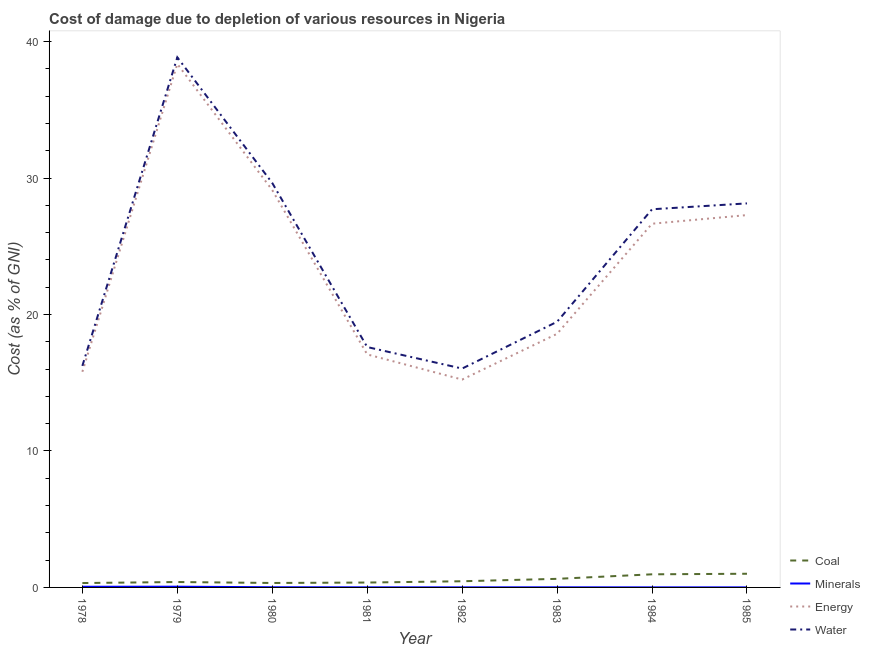Is the number of lines equal to the number of legend labels?
Provide a succinct answer. Yes. What is the cost of damage due to depletion of minerals in 1984?
Your answer should be very brief. 0.01. Across all years, what is the maximum cost of damage due to depletion of water?
Offer a terse response. 38.85. Across all years, what is the minimum cost of damage due to depletion of energy?
Keep it short and to the point. 15.24. In which year was the cost of damage due to depletion of minerals maximum?
Keep it short and to the point. 1979. In which year was the cost of damage due to depletion of energy minimum?
Make the answer very short. 1982. What is the total cost of damage due to depletion of coal in the graph?
Your response must be concise. 4.45. What is the difference between the cost of damage due to depletion of water in 1981 and that in 1982?
Ensure brevity in your answer.  1.58. What is the difference between the cost of damage due to depletion of water in 1984 and the cost of damage due to depletion of energy in 1980?
Ensure brevity in your answer.  -1.41. What is the average cost of damage due to depletion of energy per year?
Provide a succinct answer. 23.52. In the year 1979, what is the difference between the cost of damage due to depletion of energy and cost of damage due to depletion of coal?
Provide a succinct answer. 37.97. In how many years, is the cost of damage due to depletion of water greater than 32 %?
Give a very brief answer. 1. What is the ratio of the cost of damage due to depletion of energy in 1978 to that in 1979?
Provide a short and direct response. 0.41. Is the cost of damage due to depletion of energy in 1978 less than that in 1980?
Offer a very short reply. Yes. What is the difference between the highest and the second highest cost of damage due to depletion of coal?
Provide a short and direct response. 0.04. What is the difference between the highest and the lowest cost of damage due to depletion of coal?
Your response must be concise. 0.68. Is it the case that in every year, the sum of the cost of damage due to depletion of energy and cost of damage due to depletion of minerals is greater than the sum of cost of damage due to depletion of coal and cost of damage due to depletion of water?
Offer a terse response. Yes. Is it the case that in every year, the sum of the cost of damage due to depletion of coal and cost of damage due to depletion of minerals is greater than the cost of damage due to depletion of energy?
Your answer should be compact. No. Does the cost of damage due to depletion of minerals monotonically increase over the years?
Provide a succinct answer. No. Is the cost of damage due to depletion of energy strictly less than the cost of damage due to depletion of coal over the years?
Offer a very short reply. No. How many years are there in the graph?
Keep it short and to the point. 8. What is the difference between two consecutive major ticks on the Y-axis?
Your answer should be compact. 10. Are the values on the major ticks of Y-axis written in scientific E-notation?
Give a very brief answer. No. How many legend labels are there?
Your response must be concise. 4. How are the legend labels stacked?
Make the answer very short. Vertical. What is the title of the graph?
Ensure brevity in your answer.  Cost of damage due to depletion of various resources in Nigeria . Does "Offering training" appear as one of the legend labels in the graph?
Provide a succinct answer. No. What is the label or title of the Y-axis?
Make the answer very short. Cost (as % of GNI). What is the Cost (as % of GNI) of Coal in 1978?
Offer a very short reply. 0.32. What is the Cost (as % of GNI) of Minerals in 1978?
Provide a short and direct response. 0.05. What is the Cost (as % of GNI) of Energy in 1978?
Provide a succinct answer. 15.81. What is the Cost (as % of GNI) in Water in 1978?
Make the answer very short. 16.24. What is the Cost (as % of GNI) of Coal in 1979?
Provide a succinct answer. 0.4. What is the Cost (as % of GNI) of Minerals in 1979?
Offer a very short reply. 0.05. What is the Cost (as % of GNI) in Energy in 1979?
Keep it short and to the point. 38.37. What is the Cost (as % of GNI) in Water in 1979?
Provide a succinct answer. 38.85. What is the Cost (as % of GNI) in Coal in 1980?
Give a very brief answer. 0.33. What is the Cost (as % of GNI) of Minerals in 1980?
Keep it short and to the point. 0.01. What is the Cost (as % of GNI) of Energy in 1980?
Give a very brief answer. 29.12. What is the Cost (as % of GNI) of Water in 1980?
Keep it short and to the point. 29.64. What is the Cost (as % of GNI) of Coal in 1981?
Provide a short and direct response. 0.36. What is the Cost (as % of GNI) of Minerals in 1981?
Offer a very short reply. 0.01. What is the Cost (as % of GNI) in Energy in 1981?
Your answer should be very brief. 17.08. What is the Cost (as % of GNI) in Water in 1981?
Make the answer very short. 17.62. What is the Cost (as % of GNI) in Coal in 1982?
Give a very brief answer. 0.45. What is the Cost (as % of GNI) in Minerals in 1982?
Make the answer very short. 0.01. What is the Cost (as % of GNI) in Energy in 1982?
Offer a very short reply. 15.24. What is the Cost (as % of GNI) of Water in 1982?
Your answer should be very brief. 16.04. What is the Cost (as % of GNI) of Coal in 1983?
Your response must be concise. 0.63. What is the Cost (as % of GNI) in Minerals in 1983?
Offer a terse response. 0.01. What is the Cost (as % of GNI) in Energy in 1983?
Ensure brevity in your answer.  18.59. What is the Cost (as % of GNI) of Water in 1983?
Provide a short and direct response. 19.47. What is the Cost (as % of GNI) of Coal in 1984?
Provide a succinct answer. 0.96. What is the Cost (as % of GNI) of Minerals in 1984?
Offer a terse response. 0.01. What is the Cost (as % of GNI) of Energy in 1984?
Offer a terse response. 26.66. What is the Cost (as % of GNI) in Water in 1984?
Make the answer very short. 27.72. What is the Cost (as % of GNI) of Coal in 1985?
Ensure brevity in your answer.  1. What is the Cost (as % of GNI) in Minerals in 1985?
Offer a very short reply. 0. What is the Cost (as % of GNI) in Energy in 1985?
Ensure brevity in your answer.  27.29. What is the Cost (as % of GNI) in Water in 1985?
Your response must be concise. 28.15. Across all years, what is the maximum Cost (as % of GNI) in Coal?
Provide a short and direct response. 1. Across all years, what is the maximum Cost (as % of GNI) of Minerals?
Make the answer very short. 0.05. Across all years, what is the maximum Cost (as % of GNI) of Energy?
Offer a terse response. 38.37. Across all years, what is the maximum Cost (as % of GNI) of Water?
Provide a succinct answer. 38.85. Across all years, what is the minimum Cost (as % of GNI) in Coal?
Offer a very short reply. 0.32. Across all years, what is the minimum Cost (as % of GNI) in Minerals?
Your answer should be very brief. 0. Across all years, what is the minimum Cost (as % of GNI) in Energy?
Make the answer very short. 15.24. Across all years, what is the minimum Cost (as % of GNI) in Water?
Offer a very short reply. 16.04. What is the total Cost (as % of GNI) of Coal in the graph?
Provide a succinct answer. 4.45. What is the total Cost (as % of GNI) of Minerals in the graph?
Your answer should be very brief. 0.15. What is the total Cost (as % of GNI) in Energy in the graph?
Your response must be concise. 188.15. What is the total Cost (as % of GNI) in Water in the graph?
Your answer should be very brief. 193.73. What is the difference between the Cost (as % of GNI) of Coal in 1978 and that in 1979?
Provide a succinct answer. -0.08. What is the difference between the Cost (as % of GNI) of Minerals in 1978 and that in 1979?
Make the answer very short. -0. What is the difference between the Cost (as % of GNI) in Energy in 1978 and that in 1979?
Provide a succinct answer. -22.56. What is the difference between the Cost (as % of GNI) of Water in 1978 and that in 1979?
Give a very brief answer. -22.62. What is the difference between the Cost (as % of GNI) in Coal in 1978 and that in 1980?
Your answer should be very brief. -0.01. What is the difference between the Cost (as % of GNI) in Minerals in 1978 and that in 1980?
Ensure brevity in your answer.  0.04. What is the difference between the Cost (as % of GNI) of Energy in 1978 and that in 1980?
Your answer should be very brief. -13.32. What is the difference between the Cost (as % of GNI) of Water in 1978 and that in 1980?
Make the answer very short. -13.41. What is the difference between the Cost (as % of GNI) in Coal in 1978 and that in 1981?
Offer a terse response. -0.04. What is the difference between the Cost (as % of GNI) in Minerals in 1978 and that in 1981?
Offer a terse response. 0.04. What is the difference between the Cost (as % of GNI) in Energy in 1978 and that in 1981?
Keep it short and to the point. -1.27. What is the difference between the Cost (as % of GNI) of Water in 1978 and that in 1981?
Your answer should be very brief. -1.38. What is the difference between the Cost (as % of GNI) of Coal in 1978 and that in 1982?
Provide a succinct answer. -0.13. What is the difference between the Cost (as % of GNI) of Minerals in 1978 and that in 1982?
Offer a very short reply. 0.04. What is the difference between the Cost (as % of GNI) in Energy in 1978 and that in 1982?
Give a very brief answer. 0.57. What is the difference between the Cost (as % of GNI) of Water in 1978 and that in 1982?
Your answer should be very brief. 0.2. What is the difference between the Cost (as % of GNI) of Coal in 1978 and that in 1983?
Ensure brevity in your answer.  -0.31. What is the difference between the Cost (as % of GNI) of Minerals in 1978 and that in 1983?
Ensure brevity in your answer.  0.04. What is the difference between the Cost (as % of GNI) in Energy in 1978 and that in 1983?
Offer a terse response. -2.78. What is the difference between the Cost (as % of GNI) in Water in 1978 and that in 1983?
Ensure brevity in your answer.  -3.23. What is the difference between the Cost (as % of GNI) of Coal in 1978 and that in 1984?
Make the answer very short. -0.64. What is the difference between the Cost (as % of GNI) of Minerals in 1978 and that in 1984?
Offer a very short reply. 0.04. What is the difference between the Cost (as % of GNI) of Energy in 1978 and that in 1984?
Provide a short and direct response. -10.85. What is the difference between the Cost (as % of GNI) of Water in 1978 and that in 1984?
Your answer should be compact. -11.48. What is the difference between the Cost (as % of GNI) in Coal in 1978 and that in 1985?
Offer a very short reply. -0.68. What is the difference between the Cost (as % of GNI) in Minerals in 1978 and that in 1985?
Give a very brief answer. 0.05. What is the difference between the Cost (as % of GNI) of Energy in 1978 and that in 1985?
Give a very brief answer. -11.48. What is the difference between the Cost (as % of GNI) of Water in 1978 and that in 1985?
Your response must be concise. -11.91. What is the difference between the Cost (as % of GNI) in Coal in 1979 and that in 1980?
Your answer should be very brief. 0.07. What is the difference between the Cost (as % of GNI) of Minerals in 1979 and that in 1980?
Keep it short and to the point. 0.04. What is the difference between the Cost (as % of GNI) of Energy in 1979 and that in 1980?
Provide a succinct answer. 9.25. What is the difference between the Cost (as % of GNI) of Water in 1979 and that in 1980?
Your response must be concise. 9.21. What is the difference between the Cost (as % of GNI) of Coal in 1979 and that in 1981?
Keep it short and to the point. 0.04. What is the difference between the Cost (as % of GNI) in Minerals in 1979 and that in 1981?
Make the answer very short. 0.05. What is the difference between the Cost (as % of GNI) in Energy in 1979 and that in 1981?
Offer a terse response. 21.29. What is the difference between the Cost (as % of GNI) in Water in 1979 and that in 1981?
Offer a terse response. 21.24. What is the difference between the Cost (as % of GNI) of Coal in 1979 and that in 1982?
Offer a terse response. -0.06. What is the difference between the Cost (as % of GNI) of Minerals in 1979 and that in 1982?
Your response must be concise. 0.05. What is the difference between the Cost (as % of GNI) in Energy in 1979 and that in 1982?
Ensure brevity in your answer.  23.13. What is the difference between the Cost (as % of GNI) of Water in 1979 and that in 1982?
Your answer should be compact. 22.81. What is the difference between the Cost (as % of GNI) of Coal in 1979 and that in 1983?
Your answer should be very brief. -0.23. What is the difference between the Cost (as % of GNI) in Minerals in 1979 and that in 1983?
Offer a terse response. 0.05. What is the difference between the Cost (as % of GNI) of Energy in 1979 and that in 1983?
Your answer should be very brief. 19.78. What is the difference between the Cost (as % of GNI) in Water in 1979 and that in 1983?
Provide a short and direct response. 19.38. What is the difference between the Cost (as % of GNI) in Coal in 1979 and that in 1984?
Give a very brief answer. -0.56. What is the difference between the Cost (as % of GNI) in Minerals in 1979 and that in 1984?
Your response must be concise. 0.05. What is the difference between the Cost (as % of GNI) in Energy in 1979 and that in 1984?
Make the answer very short. 11.71. What is the difference between the Cost (as % of GNI) of Water in 1979 and that in 1984?
Offer a terse response. 11.14. What is the difference between the Cost (as % of GNI) of Coal in 1979 and that in 1985?
Provide a short and direct response. -0.61. What is the difference between the Cost (as % of GNI) in Minerals in 1979 and that in 1985?
Your answer should be very brief. 0.05. What is the difference between the Cost (as % of GNI) in Energy in 1979 and that in 1985?
Your response must be concise. 11.08. What is the difference between the Cost (as % of GNI) of Water in 1979 and that in 1985?
Your answer should be very brief. 10.71. What is the difference between the Cost (as % of GNI) of Coal in 1980 and that in 1981?
Your answer should be very brief. -0.03. What is the difference between the Cost (as % of GNI) of Minerals in 1980 and that in 1981?
Provide a short and direct response. 0.01. What is the difference between the Cost (as % of GNI) in Energy in 1980 and that in 1981?
Provide a succinct answer. 12.04. What is the difference between the Cost (as % of GNI) in Water in 1980 and that in 1981?
Make the answer very short. 12.02. What is the difference between the Cost (as % of GNI) in Coal in 1980 and that in 1982?
Your answer should be compact. -0.13. What is the difference between the Cost (as % of GNI) of Minerals in 1980 and that in 1982?
Ensure brevity in your answer.  0.01. What is the difference between the Cost (as % of GNI) in Energy in 1980 and that in 1982?
Ensure brevity in your answer.  13.89. What is the difference between the Cost (as % of GNI) in Water in 1980 and that in 1982?
Keep it short and to the point. 13.6. What is the difference between the Cost (as % of GNI) of Coal in 1980 and that in 1983?
Your answer should be compact. -0.3. What is the difference between the Cost (as % of GNI) of Minerals in 1980 and that in 1983?
Your answer should be very brief. 0.01. What is the difference between the Cost (as % of GNI) in Energy in 1980 and that in 1983?
Your answer should be compact. 10.54. What is the difference between the Cost (as % of GNI) in Water in 1980 and that in 1983?
Give a very brief answer. 10.17. What is the difference between the Cost (as % of GNI) of Coal in 1980 and that in 1984?
Offer a terse response. -0.64. What is the difference between the Cost (as % of GNI) in Minerals in 1980 and that in 1984?
Your answer should be compact. 0.01. What is the difference between the Cost (as % of GNI) in Energy in 1980 and that in 1984?
Give a very brief answer. 2.46. What is the difference between the Cost (as % of GNI) of Water in 1980 and that in 1984?
Keep it short and to the point. 1.93. What is the difference between the Cost (as % of GNI) of Coal in 1980 and that in 1985?
Provide a short and direct response. -0.68. What is the difference between the Cost (as % of GNI) in Minerals in 1980 and that in 1985?
Offer a terse response. 0.01. What is the difference between the Cost (as % of GNI) in Energy in 1980 and that in 1985?
Provide a short and direct response. 1.83. What is the difference between the Cost (as % of GNI) in Water in 1980 and that in 1985?
Your answer should be compact. 1.5. What is the difference between the Cost (as % of GNI) in Coal in 1981 and that in 1982?
Give a very brief answer. -0.09. What is the difference between the Cost (as % of GNI) in Minerals in 1981 and that in 1982?
Keep it short and to the point. 0. What is the difference between the Cost (as % of GNI) of Energy in 1981 and that in 1982?
Your answer should be very brief. 1.84. What is the difference between the Cost (as % of GNI) in Water in 1981 and that in 1982?
Provide a short and direct response. 1.58. What is the difference between the Cost (as % of GNI) of Coal in 1981 and that in 1983?
Offer a very short reply. -0.27. What is the difference between the Cost (as % of GNI) of Minerals in 1981 and that in 1983?
Give a very brief answer. -0. What is the difference between the Cost (as % of GNI) of Energy in 1981 and that in 1983?
Offer a very short reply. -1.51. What is the difference between the Cost (as % of GNI) in Water in 1981 and that in 1983?
Ensure brevity in your answer.  -1.85. What is the difference between the Cost (as % of GNI) in Coal in 1981 and that in 1984?
Offer a very short reply. -0.6. What is the difference between the Cost (as % of GNI) in Minerals in 1981 and that in 1984?
Make the answer very short. 0. What is the difference between the Cost (as % of GNI) in Energy in 1981 and that in 1984?
Offer a very short reply. -9.58. What is the difference between the Cost (as % of GNI) of Water in 1981 and that in 1984?
Give a very brief answer. -10.1. What is the difference between the Cost (as % of GNI) of Coal in 1981 and that in 1985?
Offer a very short reply. -0.64. What is the difference between the Cost (as % of GNI) in Minerals in 1981 and that in 1985?
Make the answer very short. 0. What is the difference between the Cost (as % of GNI) in Energy in 1981 and that in 1985?
Offer a very short reply. -10.21. What is the difference between the Cost (as % of GNI) of Water in 1981 and that in 1985?
Your response must be concise. -10.53. What is the difference between the Cost (as % of GNI) in Coal in 1982 and that in 1983?
Your answer should be very brief. -0.18. What is the difference between the Cost (as % of GNI) of Minerals in 1982 and that in 1983?
Your response must be concise. -0. What is the difference between the Cost (as % of GNI) in Energy in 1982 and that in 1983?
Your answer should be compact. -3.35. What is the difference between the Cost (as % of GNI) in Water in 1982 and that in 1983?
Provide a succinct answer. -3.43. What is the difference between the Cost (as % of GNI) in Coal in 1982 and that in 1984?
Ensure brevity in your answer.  -0.51. What is the difference between the Cost (as % of GNI) of Minerals in 1982 and that in 1984?
Keep it short and to the point. 0. What is the difference between the Cost (as % of GNI) in Energy in 1982 and that in 1984?
Your answer should be compact. -11.42. What is the difference between the Cost (as % of GNI) of Water in 1982 and that in 1984?
Ensure brevity in your answer.  -11.68. What is the difference between the Cost (as % of GNI) in Coal in 1982 and that in 1985?
Ensure brevity in your answer.  -0.55. What is the difference between the Cost (as % of GNI) in Minerals in 1982 and that in 1985?
Provide a short and direct response. 0. What is the difference between the Cost (as % of GNI) of Energy in 1982 and that in 1985?
Your answer should be compact. -12.06. What is the difference between the Cost (as % of GNI) of Water in 1982 and that in 1985?
Provide a succinct answer. -12.11. What is the difference between the Cost (as % of GNI) of Coal in 1983 and that in 1984?
Your answer should be compact. -0.33. What is the difference between the Cost (as % of GNI) of Minerals in 1983 and that in 1984?
Your answer should be very brief. 0. What is the difference between the Cost (as % of GNI) of Energy in 1983 and that in 1984?
Offer a terse response. -8.07. What is the difference between the Cost (as % of GNI) in Water in 1983 and that in 1984?
Keep it short and to the point. -8.25. What is the difference between the Cost (as % of GNI) of Coal in 1983 and that in 1985?
Your response must be concise. -0.37. What is the difference between the Cost (as % of GNI) in Minerals in 1983 and that in 1985?
Your answer should be very brief. 0. What is the difference between the Cost (as % of GNI) of Energy in 1983 and that in 1985?
Offer a terse response. -8.7. What is the difference between the Cost (as % of GNI) in Water in 1983 and that in 1985?
Offer a terse response. -8.68. What is the difference between the Cost (as % of GNI) in Coal in 1984 and that in 1985?
Ensure brevity in your answer.  -0.04. What is the difference between the Cost (as % of GNI) in Minerals in 1984 and that in 1985?
Provide a short and direct response. 0. What is the difference between the Cost (as % of GNI) in Energy in 1984 and that in 1985?
Your answer should be compact. -0.63. What is the difference between the Cost (as % of GNI) of Water in 1984 and that in 1985?
Provide a succinct answer. -0.43. What is the difference between the Cost (as % of GNI) of Coal in 1978 and the Cost (as % of GNI) of Minerals in 1979?
Keep it short and to the point. 0.27. What is the difference between the Cost (as % of GNI) in Coal in 1978 and the Cost (as % of GNI) in Energy in 1979?
Keep it short and to the point. -38.05. What is the difference between the Cost (as % of GNI) of Coal in 1978 and the Cost (as % of GNI) of Water in 1979?
Make the answer very short. -38.53. What is the difference between the Cost (as % of GNI) in Minerals in 1978 and the Cost (as % of GNI) in Energy in 1979?
Your response must be concise. -38.32. What is the difference between the Cost (as % of GNI) of Minerals in 1978 and the Cost (as % of GNI) of Water in 1979?
Ensure brevity in your answer.  -38.8. What is the difference between the Cost (as % of GNI) in Energy in 1978 and the Cost (as % of GNI) in Water in 1979?
Provide a short and direct response. -23.05. What is the difference between the Cost (as % of GNI) in Coal in 1978 and the Cost (as % of GNI) in Minerals in 1980?
Your answer should be compact. 0.31. What is the difference between the Cost (as % of GNI) of Coal in 1978 and the Cost (as % of GNI) of Energy in 1980?
Offer a terse response. -28.8. What is the difference between the Cost (as % of GNI) in Coal in 1978 and the Cost (as % of GNI) in Water in 1980?
Ensure brevity in your answer.  -29.32. What is the difference between the Cost (as % of GNI) of Minerals in 1978 and the Cost (as % of GNI) of Energy in 1980?
Give a very brief answer. -29.07. What is the difference between the Cost (as % of GNI) in Minerals in 1978 and the Cost (as % of GNI) in Water in 1980?
Keep it short and to the point. -29.59. What is the difference between the Cost (as % of GNI) of Energy in 1978 and the Cost (as % of GNI) of Water in 1980?
Provide a succinct answer. -13.84. What is the difference between the Cost (as % of GNI) in Coal in 1978 and the Cost (as % of GNI) in Minerals in 1981?
Provide a succinct answer. 0.31. What is the difference between the Cost (as % of GNI) of Coal in 1978 and the Cost (as % of GNI) of Energy in 1981?
Give a very brief answer. -16.76. What is the difference between the Cost (as % of GNI) in Coal in 1978 and the Cost (as % of GNI) in Water in 1981?
Provide a short and direct response. -17.3. What is the difference between the Cost (as % of GNI) of Minerals in 1978 and the Cost (as % of GNI) of Energy in 1981?
Keep it short and to the point. -17.03. What is the difference between the Cost (as % of GNI) in Minerals in 1978 and the Cost (as % of GNI) in Water in 1981?
Your answer should be very brief. -17.57. What is the difference between the Cost (as % of GNI) of Energy in 1978 and the Cost (as % of GNI) of Water in 1981?
Offer a terse response. -1.81. What is the difference between the Cost (as % of GNI) of Coal in 1978 and the Cost (as % of GNI) of Minerals in 1982?
Offer a very short reply. 0.32. What is the difference between the Cost (as % of GNI) of Coal in 1978 and the Cost (as % of GNI) of Energy in 1982?
Provide a short and direct response. -14.91. What is the difference between the Cost (as % of GNI) of Coal in 1978 and the Cost (as % of GNI) of Water in 1982?
Keep it short and to the point. -15.72. What is the difference between the Cost (as % of GNI) in Minerals in 1978 and the Cost (as % of GNI) in Energy in 1982?
Your response must be concise. -15.19. What is the difference between the Cost (as % of GNI) of Minerals in 1978 and the Cost (as % of GNI) of Water in 1982?
Offer a terse response. -15.99. What is the difference between the Cost (as % of GNI) in Energy in 1978 and the Cost (as % of GNI) in Water in 1982?
Provide a short and direct response. -0.24. What is the difference between the Cost (as % of GNI) in Coal in 1978 and the Cost (as % of GNI) in Minerals in 1983?
Offer a very short reply. 0.31. What is the difference between the Cost (as % of GNI) of Coal in 1978 and the Cost (as % of GNI) of Energy in 1983?
Offer a very short reply. -18.27. What is the difference between the Cost (as % of GNI) in Coal in 1978 and the Cost (as % of GNI) in Water in 1983?
Your answer should be very brief. -19.15. What is the difference between the Cost (as % of GNI) of Minerals in 1978 and the Cost (as % of GNI) of Energy in 1983?
Ensure brevity in your answer.  -18.54. What is the difference between the Cost (as % of GNI) in Minerals in 1978 and the Cost (as % of GNI) in Water in 1983?
Provide a short and direct response. -19.42. What is the difference between the Cost (as % of GNI) of Energy in 1978 and the Cost (as % of GNI) of Water in 1983?
Ensure brevity in your answer.  -3.67. What is the difference between the Cost (as % of GNI) of Coal in 1978 and the Cost (as % of GNI) of Minerals in 1984?
Keep it short and to the point. 0.32. What is the difference between the Cost (as % of GNI) in Coal in 1978 and the Cost (as % of GNI) in Energy in 1984?
Offer a terse response. -26.34. What is the difference between the Cost (as % of GNI) of Coal in 1978 and the Cost (as % of GNI) of Water in 1984?
Give a very brief answer. -27.4. What is the difference between the Cost (as % of GNI) of Minerals in 1978 and the Cost (as % of GNI) of Energy in 1984?
Ensure brevity in your answer.  -26.61. What is the difference between the Cost (as % of GNI) of Minerals in 1978 and the Cost (as % of GNI) of Water in 1984?
Your response must be concise. -27.67. What is the difference between the Cost (as % of GNI) in Energy in 1978 and the Cost (as % of GNI) in Water in 1984?
Make the answer very short. -11.91. What is the difference between the Cost (as % of GNI) of Coal in 1978 and the Cost (as % of GNI) of Minerals in 1985?
Your answer should be compact. 0.32. What is the difference between the Cost (as % of GNI) in Coal in 1978 and the Cost (as % of GNI) in Energy in 1985?
Keep it short and to the point. -26.97. What is the difference between the Cost (as % of GNI) of Coal in 1978 and the Cost (as % of GNI) of Water in 1985?
Give a very brief answer. -27.83. What is the difference between the Cost (as % of GNI) in Minerals in 1978 and the Cost (as % of GNI) in Energy in 1985?
Provide a succinct answer. -27.24. What is the difference between the Cost (as % of GNI) of Minerals in 1978 and the Cost (as % of GNI) of Water in 1985?
Offer a terse response. -28.1. What is the difference between the Cost (as % of GNI) of Energy in 1978 and the Cost (as % of GNI) of Water in 1985?
Make the answer very short. -12.34. What is the difference between the Cost (as % of GNI) of Coal in 1979 and the Cost (as % of GNI) of Minerals in 1980?
Make the answer very short. 0.38. What is the difference between the Cost (as % of GNI) in Coal in 1979 and the Cost (as % of GNI) in Energy in 1980?
Your answer should be compact. -28.73. What is the difference between the Cost (as % of GNI) in Coal in 1979 and the Cost (as % of GNI) in Water in 1980?
Make the answer very short. -29.25. What is the difference between the Cost (as % of GNI) of Minerals in 1979 and the Cost (as % of GNI) of Energy in 1980?
Your answer should be compact. -29.07. What is the difference between the Cost (as % of GNI) of Minerals in 1979 and the Cost (as % of GNI) of Water in 1980?
Make the answer very short. -29.59. What is the difference between the Cost (as % of GNI) in Energy in 1979 and the Cost (as % of GNI) in Water in 1980?
Provide a succinct answer. 8.73. What is the difference between the Cost (as % of GNI) of Coal in 1979 and the Cost (as % of GNI) of Minerals in 1981?
Make the answer very short. 0.39. What is the difference between the Cost (as % of GNI) in Coal in 1979 and the Cost (as % of GNI) in Energy in 1981?
Offer a very short reply. -16.68. What is the difference between the Cost (as % of GNI) in Coal in 1979 and the Cost (as % of GNI) in Water in 1981?
Provide a succinct answer. -17.22. What is the difference between the Cost (as % of GNI) of Minerals in 1979 and the Cost (as % of GNI) of Energy in 1981?
Your answer should be very brief. -17.03. What is the difference between the Cost (as % of GNI) of Minerals in 1979 and the Cost (as % of GNI) of Water in 1981?
Ensure brevity in your answer.  -17.56. What is the difference between the Cost (as % of GNI) in Energy in 1979 and the Cost (as % of GNI) in Water in 1981?
Offer a very short reply. 20.75. What is the difference between the Cost (as % of GNI) of Coal in 1979 and the Cost (as % of GNI) of Minerals in 1982?
Provide a succinct answer. 0.39. What is the difference between the Cost (as % of GNI) in Coal in 1979 and the Cost (as % of GNI) in Energy in 1982?
Provide a short and direct response. -14.84. What is the difference between the Cost (as % of GNI) of Coal in 1979 and the Cost (as % of GNI) of Water in 1982?
Ensure brevity in your answer.  -15.65. What is the difference between the Cost (as % of GNI) in Minerals in 1979 and the Cost (as % of GNI) in Energy in 1982?
Your answer should be very brief. -15.18. What is the difference between the Cost (as % of GNI) of Minerals in 1979 and the Cost (as % of GNI) of Water in 1982?
Your response must be concise. -15.99. What is the difference between the Cost (as % of GNI) in Energy in 1979 and the Cost (as % of GNI) in Water in 1982?
Provide a short and direct response. 22.33. What is the difference between the Cost (as % of GNI) in Coal in 1979 and the Cost (as % of GNI) in Minerals in 1983?
Your answer should be compact. 0.39. What is the difference between the Cost (as % of GNI) in Coal in 1979 and the Cost (as % of GNI) in Energy in 1983?
Give a very brief answer. -18.19. What is the difference between the Cost (as % of GNI) of Coal in 1979 and the Cost (as % of GNI) of Water in 1983?
Provide a short and direct response. -19.08. What is the difference between the Cost (as % of GNI) in Minerals in 1979 and the Cost (as % of GNI) in Energy in 1983?
Offer a terse response. -18.53. What is the difference between the Cost (as % of GNI) of Minerals in 1979 and the Cost (as % of GNI) of Water in 1983?
Your response must be concise. -19.42. What is the difference between the Cost (as % of GNI) in Energy in 1979 and the Cost (as % of GNI) in Water in 1983?
Offer a terse response. 18.9. What is the difference between the Cost (as % of GNI) of Coal in 1979 and the Cost (as % of GNI) of Minerals in 1984?
Offer a very short reply. 0.39. What is the difference between the Cost (as % of GNI) of Coal in 1979 and the Cost (as % of GNI) of Energy in 1984?
Offer a terse response. -26.26. What is the difference between the Cost (as % of GNI) in Coal in 1979 and the Cost (as % of GNI) in Water in 1984?
Offer a terse response. -27.32. What is the difference between the Cost (as % of GNI) of Minerals in 1979 and the Cost (as % of GNI) of Energy in 1984?
Keep it short and to the point. -26.6. What is the difference between the Cost (as % of GNI) in Minerals in 1979 and the Cost (as % of GNI) in Water in 1984?
Your response must be concise. -27.66. What is the difference between the Cost (as % of GNI) of Energy in 1979 and the Cost (as % of GNI) of Water in 1984?
Provide a short and direct response. 10.65. What is the difference between the Cost (as % of GNI) in Coal in 1979 and the Cost (as % of GNI) in Minerals in 1985?
Your answer should be compact. 0.39. What is the difference between the Cost (as % of GNI) of Coal in 1979 and the Cost (as % of GNI) of Energy in 1985?
Keep it short and to the point. -26.89. What is the difference between the Cost (as % of GNI) of Coal in 1979 and the Cost (as % of GNI) of Water in 1985?
Provide a short and direct response. -27.75. What is the difference between the Cost (as % of GNI) of Minerals in 1979 and the Cost (as % of GNI) of Energy in 1985?
Provide a succinct answer. -27.24. What is the difference between the Cost (as % of GNI) in Minerals in 1979 and the Cost (as % of GNI) in Water in 1985?
Your response must be concise. -28.09. What is the difference between the Cost (as % of GNI) in Energy in 1979 and the Cost (as % of GNI) in Water in 1985?
Your response must be concise. 10.22. What is the difference between the Cost (as % of GNI) in Coal in 1980 and the Cost (as % of GNI) in Minerals in 1981?
Provide a succinct answer. 0.32. What is the difference between the Cost (as % of GNI) in Coal in 1980 and the Cost (as % of GNI) in Energy in 1981?
Keep it short and to the point. -16.75. What is the difference between the Cost (as % of GNI) in Coal in 1980 and the Cost (as % of GNI) in Water in 1981?
Keep it short and to the point. -17.29. What is the difference between the Cost (as % of GNI) of Minerals in 1980 and the Cost (as % of GNI) of Energy in 1981?
Ensure brevity in your answer.  -17.07. What is the difference between the Cost (as % of GNI) in Minerals in 1980 and the Cost (as % of GNI) in Water in 1981?
Your answer should be very brief. -17.61. What is the difference between the Cost (as % of GNI) in Energy in 1980 and the Cost (as % of GNI) in Water in 1981?
Give a very brief answer. 11.5. What is the difference between the Cost (as % of GNI) in Coal in 1980 and the Cost (as % of GNI) in Minerals in 1982?
Your answer should be compact. 0.32. What is the difference between the Cost (as % of GNI) of Coal in 1980 and the Cost (as % of GNI) of Energy in 1982?
Provide a succinct answer. -14.91. What is the difference between the Cost (as % of GNI) in Coal in 1980 and the Cost (as % of GNI) in Water in 1982?
Offer a very short reply. -15.72. What is the difference between the Cost (as % of GNI) of Minerals in 1980 and the Cost (as % of GNI) of Energy in 1982?
Offer a terse response. -15.22. What is the difference between the Cost (as % of GNI) of Minerals in 1980 and the Cost (as % of GNI) of Water in 1982?
Provide a short and direct response. -16.03. What is the difference between the Cost (as % of GNI) in Energy in 1980 and the Cost (as % of GNI) in Water in 1982?
Keep it short and to the point. 13.08. What is the difference between the Cost (as % of GNI) in Coal in 1980 and the Cost (as % of GNI) in Minerals in 1983?
Offer a very short reply. 0.32. What is the difference between the Cost (as % of GNI) of Coal in 1980 and the Cost (as % of GNI) of Energy in 1983?
Keep it short and to the point. -18.26. What is the difference between the Cost (as % of GNI) in Coal in 1980 and the Cost (as % of GNI) in Water in 1983?
Offer a very short reply. -19.15. What is the difference between the Cost (as % of GNI) in Minerals in 1980 and the Cost (as % of GNI) in Energy in 1983?
Give a very brief answer. -18.57. What is the difference between the Cost (as % of GNI) in Minerals in 1980 and the Cost (as % of GNI) in Water in 1983?
Ensure brevity in your answer.  -19.46. What is the difference between the Cost (as % of GNI) of Energy in 1980 and the Cost (as % of GNI) of Water in 1983?
Your response must be concise. 9.65. What is the difference between the Cost (as % of GNI) in Coal in 1980 and the Cost (as % of GNI) in Minerals in 1984?
Make the answer very short. 0.32. What is the difference between the Cost (as % of GNI) of Coal in 1980 and the Cost (as % of GNI) of Energy in 1984?
Provide a short and direct response. -26.33. What is the difference between the Cost (as % of GNI) in Coal in 1980 and the Cost (as % of GNI) in Water in 1984?
Offer a terse response. -27.39. What is the difference between the Cost (as % of GNI) of Minerals in 1980 and the Cost (as % of GNI) of Energy in 1984?
Provide a succinct answer. -26.64. What is the difference between the Cost (as % of GNI) of Minerals in 1980 and the Cost (as % of GNI) of Water in 1984?
Your answer should be compact. -27.7. What is the difference between the Cost (as % of GNI) in Energy in 1980 and the Cost (as % of GNI) in Water in 1984?
Provide a succinct answer. 1.41. What is the difference between the Cost (as % of GNI) in Coal in 1980 and the Cost (as % of GNI) in Minerals in 1985?
Make the answer very short. 0.32. What is the difference between the Cost (as % of GNI) in Coal in 1980 and the Cost (as % of GNI) in Energy in 1985?
Provide a short and direct response. -26.96. What is the difference between the Cost (as % of GNI) in Coal in 1980 and the Cost (as % of GNI) in Water in 1985?
Give a very brief answer. -27.82. What is the difference between the Cost (as % of GNI) of Minerals in 1980 and the Cost (as % of GNI) of Energy in 1985?
Keep it short and to the point. -27.28. What is the difference between the Cost (as % of GNI) of Minerals in 1980 and the Cost (as % of GNI) of Water in 1985?
Offer a very short reply. -28.13. What is the difference between the Cost (as % of GNI) in Energy in 1980 and the Cost (as % of GNI) in Water in 1985?
Offer a very short reply. 0.98. What is the difference between the Cost (as % of GNI) in Coal in 1981 and the Cost (as % of GNI) in Minerals in 1982?
Your answer should be very brief. 0.35. What is the difference between the Cost (as % of GNI) in Coal in 1981 and the Cost (as % of GNI) in Energy in 1982?
Ensure brevity in your answer.  -14.88. What is the difference between the Cost (as % of GNI) in Coal in 1981 and the Cost (as % of GNI) in Water in 1982?
Provide a short and direct response. -15.68. What is the difference between the Cost (as % of GNI) of Minerals in 1981 and the Cost (as % of GNI) of Energy in 1982?
Your answer should be very brief. -15.23. What is the difference between the Cost (as % of GNI) of Minerals in 1981 and the Cost (as % of GNI) of Water in 1982?
Your answer should be very brief. -16.03. What is the difference between the Cost (as % of GNI) in Energy in 1981 and the Cost (as % of GNI) in Water in 1982?
Your answer should be compact. 1.04. What is the difference between the Cost (as % of GNI) of Coal in 1981 and the Cost (as % of GNI) of Minerals in 1983?
Provide a short and direct response. 0.35. What is the difference between the Cost (as % of GNI) in Coal in 1981 and the Cost (as % of GNI) in Energy in 1983?
Provide a short and direct response. -18.23. What is the difference between the Cost (as % of GNI) in Coal in 1981 and the Cost (as % of GNI) in Water in 1983?
Your answer should be very brief. -19.11. What is the difference between the Cost (as % of GNI) of Minerals in 1981 and the Cost (as % of GNI) of Energy in 1983?
Keep it short and to the point. -18.58. What is the difference between the Cost (as % of GNI) in Minerals in 1981 and the Cost (as % of GNI) in Water in 1983?
Make the answer very short. -19.46. What is the difference between the Cost (as % of GNI) in Energy in 1981 and the Cost (as % of GNI) in Water in 1983?
Provide a short and direct response. -2.39. What is the difference between the Cost (as % of GNI) in Coal in 1981 and the Cost (as % of GNI) in Minerals in 1984?
Provide a short and direct response. 0.35. What is the difference between the Cost (as % of GNI) in Coal in 1981 and the Cost (as % of GNI) in Energy in 1984?
Give a very brief answer. -26.3. What is the difference between the Cost (as % of GNI) of Coal in 1981 and the Cost (as % of GNI) of Water in 1984?
Offer a very short reply. -27.36. What is the difference between the Cost (as % of GNI) in Minerals in 1981 and the Cost (as % of GNI) in Energy in 1984?
Make the answer very short. -26.65. What is the difference between the Cost (as % of GNI) of Minerals in 1981 and the Cost (as % of GNI) of Water in 1984?
Provide a short and direct response. -27.71. What is the difference between the Cost (as % of GNI) of Energy in 1981 and the Cost (as % of GNI) of Water in 1984?
Your response must be concise. -10.64. What is the difference between the Cost (as % of GNI) in Coal in 1981 and the Cost (as % of GNI) in Minerals in 1985?
Your response must be concise. 0.35. What is the difference between the Cost (as % of GNI) in Coal in 1981 and the Cost (as % of GNI) in Energy in 1985?
Provide a succinct answer. -26.93. What is the difference between the Cost (as % of GNI) in Coal in 1981 and the Cost (as % of GNI) in Water in 1985?
Provide a succinct answer. -27.79. What is the difference between the Cost (as % of GNI) of Minerals in 1981 and the Cost (as % of GNI) of Energy in 1985?
Give a very brief answer. -27.28. What is the difference between the Cost (as % of GNI) of Minerals in 1981 and the Cost (as % of GNI) of Water in 1985?
Your response must be concise. -28.14. What is the difference between the Cost (as % of GNI) in Energy in 1981 and the Cost (as % of GNI) in Water in 1985?
Offer a very short reply. -11.07. What is the difference between the Cost (as % of GNI) of Coal in 1982 and the Cost (as % of GNI) of Minerals in 1983?
Give a very brief answer. 0.44. What is the difference between the Cost (as % of GNI) in Coal in 1982 and the Cost (as % of GNI) in Energy in 1983?
Give a very brief answer. -18.14. What is the difference between the Cost (as % of GNI) in Coal in 1982 and the Cost (as % of GNI) in Water in 1983?
Keep it short and to the point. -19.02. What is the difference between the Cost (as % of GNI) in Minerals in 1982 and the Cost (as % of GNI) in Energy in 1983?
Offer a terse response. -18.58. What is the difference between the Cost (as % of GNI) of Minerals in 1982 and the Cost (as % of GNI) of Water in 1983?
Provide a succinct answer. -19.47. What is the difference between the Cost (as % of GNI) in Energy in 1982 and the Cost (as % of GNI) in Water in 1983?
Keep it short and to the point. -4.24. What is the difference between the Cost (as % of GNI) of Coal in 1982 and the Cost (as % of GNI) of Minerals in 1984?
Make the answer very short. 0.45. What is the difference between the Cost (as % of GNI) in Coal in 1982 and the Cost (as % of GNI) in Energy in 1984?
Ensure brevity in your answer.  -26.21. What is the difference between the Cost (as % of GNI) in Coal in 1982 and the Cost (as % of GNI) in Water in 1984?
Provide a succinct answer. -27.26. What is the difference between the Cost (as % of GNI) of Minerals in 1982 and the Cost (as % of GNI) of Energy in 1984?
Make the answer very short. -26.65. What is the difference between the Cost (as % of GNI) in Minerals in 1982 and the Cost (as % of GNI) in Water in 1984?
Ensure brevity in your answer.  -27.71. What is the difference between the Cost (as % of GNI) in Energy in 1982 and the Cost (as % of GNI) in Water in 1984?
Provide a short and direct response. -12.48. What is the difference between the Cost (as % of GNI) of Coal in 1982 and the Cost (as % of GNI) of Minerals in 1985?
Provide a short and direct response. 0.45. What is the difference between the Cost (as % of GNI) in Coal in 1982 and the Cost (as % of GNI) in Energy in 1985?
Offer a terse response. -26.84. What is the difference between the Cost (as % of GNI) of Coal in 1982 and the Cost (as % of GNI) of Water in 1985?
Give a very brief answer. -27.7. What is the difference between the Cost (as % of GNI) in Minerals in 1982 and the Cost (as % of GNI) in Energy in 1985?
Your response must be concise. -27.28. What is the difference between the Cost (as % of GNI) in Minerals in 1982 and the Cost (as % of GNI) in Water in 1985?
Provide a short and direct response. -28.14. What is the difference between the Cost (as % of GNI) in Energy in 1982 and the Cost (as % of GNI) in Water in 1985?
Your answer should be very brief. -12.91. What is the difference between the Cost (as % of GNI) of Coal in 1983 and the Cost (as % of GNI) of Minerals in 1984?
Provide a succinct answer. 0.62. What is the difference between the Cost (as % of GNI) in Coal in 1983 and the Cost (as % of GNI) in Energy in 1984?
Your response must be concise. -26.03. What is the difference between the Cost (as % of GNI) of Coal in 1983 and the Cost (as % of GNI) of Water in 1984?
Your response must be concise. -27.09. What is the difference between the Cost (as % of GNI) in Minerals in 1983 and the Cost (as % of GNI) in Energy in 1984?
Your answer should be very brief. -26.65. What is the difference between the Cost (as % of GNI) of Minerals in 1983 and the Cost (as % of GNI) of Water in 1984?
Provide a short and direct response. -27.71. What is the difference between the Cost (as % of GNI) of Energy in 1983 and the Cost (as % of GNI) of Water in 1984?
Your answer should be very brief. -9.13. What is the difference between the Cost (as % of GNI) of Coal in 1983 and the Cost (as % of GNI) of Energy in 1985?
Offer a terse response. -26.66. What is the difference between the Cost (as % of GNI) of Coal in 1983 and the Cost (as % of GNI) of Water in 1985?
Your answer should be compact. -27.52. What is the difference between the Cost (as % of GNI) in Minerals in 1983 and the Cost (as % of GNI) in Energy in 1985?
Offer a terse response. -27.28. What is the difference between the Cost (as % of GNI) in Minerals in 1983 and the Cost (as % of GNI) in Water in 1985?
Ensure brevity in your answer.  -28.14. What is the difference between the Cost (as % of GNI) of Energy in 1983 and the Cost (as % of GNI) of Water in 1985?
Provide a succinct answer. -9.56. What is the difference between the Cost (as % of GNI) of Coal in 1984 and the Cost (as % of GNI) of Minerals in 1985?
Offer a very short reply. 0.96. What is the difference between the Cost (as % of GNI) in Coal in 1984 and the Cost (as % of GNI) in Energy in 1985?
Offer a very short reply. -26.33. What is the difference between the Cost (as % of GNI) of Coal in 1984 and the Cost (as % of GNI) of Water in 1985?
Give a very brief answer. -27.19. What is the difference between the Cost (as % of GNI) in Minerals in 1984 and the Cost (as % of GNI) in Energy in 1985?
Your answer should be very brief. -27.29. What is the difference between the Cost (as % of GNI) in Minerals in 1984 and the Cost (as % of GNI) in Water in 1985?
Provide a succinct answer. -28.14. What is the difference between the Cost (as % of GNI) of Energy in 1984 and the Cost (as % of GNI) of Water in 1985?
Give a very brief answer. -1.49. What is the average Cost (as % of GNI) of Coal per year?
Provide a short and direct response. 0.56. What is the average Cost (as % of GNI) of Minerals per year?
Your response must be concise. 0.02. What is the average Cost (as % of GNI) in Energy per year?
Keep it short and to the point. 23.52. What is the average Cost (as % of GNI) in Water per year?
Provide a succinct answer. 24.22. In the year 1978, what is the difference between the Cost (as % of GNI) of Coal and Cost (as % of GNI) of Minerals?
Your answer should be compact. 0.27. In the year 1978, what is the difference between the Cost (as % of GNI) of Coal and Cost (as % of GNI) of Energy?
Provide a short and direct response. -15.49. In the year 1978, what is the difference between the Cost (as % of GNI) of Coal and Cost (as % of GNI) of Water?
Your response must be concise. -15.92. In the year 1978, what is the difference between the Cost (as % of GNI) in Minerals and Cost (as % of GNI) in Energy?
Provide a succinct answer. -15.76. In the year 1978, what is the difference between the Cost (as % of GNI) of Minerals and Cost (as % of GNI) of Water?
Your response must be concise. -16.19. In the year 1978, what is the difference between the Cost (as % of GNI) of Energy and Cost (as % of GNI) of Water?
Provide a short and direct response. -0.43. In the year 1979, what is the difference between the Cost (as % of GNI) of Coal and Cost (as % of GNI) of Minerals?
Your response must be concise. 0.34. In the year 1979, what is the difference between the Cost (as % of GNI) in Coal and Cost (as % of GNI) in Energy?
Give a very brief answer. -37.97. In the year 1979, what is the difference between the Cost (as % of GNI) in Coal and Cost (as % of GNI) in Water?
Offer a terse response. -38.46. In the year 1979, what is the difference between the Cost (as % of GNI) of Minerals and Cost (as % of GNI) of Energy?
Your answer should be compact. -38.31. In the year 1979, what is the difference between the Cost (as % of GNI) of Minerals and Cost (as % of GNI) of Water?
Offer a terse response. -38.8. In the year 1979, what is the difference between the Cost (as % of GNI) in Energy and Cost (as % of GNI) in Water?
Your answer should be very brief. -0.49. In the year 1980, what is the difference between the Cost (as % of GNI) of Coal and Cost (as % of GNI) of Minerals?
Your answer should be compact. 0.31. In the year 1980, what is the difference between the Cost (as % of GNI) in Coal and Cost (as % of GNI) in Energy?
Make the answer very short. -28.8. In the year 1980, what is the difference between the Cost (as % of GNI) of Coal and Cost (as % of GNI) of Water?
Offer a terse response. -29.32. In the year 1980, what is the difference between the Cost (as % of GNI) of Minerals and Cost (as % of GNI) of Energy?
Your answer should be compact. -29.11. In the year 1980, what is the difference between the Cost (as % of GNI) of Minerals and Cost (as % of GNI) of Water?
Your answer should be very brief. -29.63. In the year 1980, what is the difference between the Cost (as % of GNI) in Energy and Cost (as % of GNI) in Water?
Your answer should be compact. -0.52. In the year 1981, what is the difference between the Cost (as % of GNI) in Coal and Cost (as % of GNI) in Minerals?
Ensure brevity in your answer.  0.35. In the year 1981, what is the difference between the Cost (as % of GNI) of Coal and Cost (as % of GNI) of Energy?
Give a very brief answer. -16.72. In the year 1981, what is the difference between the Cost (as % of GNI) in Coal and Cost (as % of GNI) in Water?
Your answer should be compact. -17.26. In the year 1981, what is the difference between the Cost (as % of GNI) of Minerals and Cost (as % of GNI) of Energy?
Provide a short and direct response. -17.07. In the year 1981, what is the difference between the Cost (as % of GNI) in Minerals and Cost (as % of GNI) in Water?
Keep it short and to the point. -17.61. In the year 1981, what is the difference between the Cost (as % of GNI) of Energy and Cost (as % of GNI) of Water?
Provide a succinct answer. -0.54. In the year 1982, what is the difference between the Cost (as % of GNI) in Coal and Cost (as % of GNI) in Minerals?
Provide a short and direct response. 0.45. In the year 1982, what is the difference between the Cost (as % of GNI) of Coal and Cost (as % of GNI) of Energy?
Keep it short and to the point. -14.78. In the year 1982, what is the difference between the Cost (as % of GNI) of Coal and Cost (as % of GNI) of Water?
Your answer should be very brief. -15.59. In the year 1982, what is the difference between the Cost (as % of GNI) in Minerals and Cost (as % of GNI) in Energy?
Keep it short and to the point. -15.23. In the year 1982, what is the difference between the Cost (as % of GNI) in Minerals and Cost (as % of GNI) in Water?
Offer a terse response. -16.04. In the year 1982, what is the difference between the Cost (as % of GNI) of Energy and Cost (as % of GNI) of Water?
Provide a short and direct response. -0.81. In the year 1983, what is the difference between the Cost (as % of GNI) in Coal and Cost (as % of GNI) in Minerals?
Your answer should be compact. 0.62. In the year 1983, what is the difference between the Cost (as % of GNI) in Coal and Cost (as % of GNI) in Energy?
Your answer should be compact. -17.96. In the year 1983, what is the difference between the Cost (as % of GNI) in Coal and Cost (as % of GNI) in Water?
Make the answer very short. -18.84. In the year 1983, what is the difference between the Cost (as % of GNI) of Minerals and Cost (as % of GNI) of Energy?
Give a very brief answer. -18.58. In the year 1983, what is the difference between the Cost (as % of GNI) in Minerals and Cost (as % of GNI) in Water?
Make the answer very short. -19.46. In the year 1983, what is the difference between the Cost (as % of GNI) of Energy and Cost (as % of GNI) of Water?
Your answer should be compact. -0.88. In the year 1984, what is the difference between the Cost (as % of GNI) of Coal and Cost (as % of GNI) of Minerals?
Your response must be concise. 0.96. In the year 1984, what is the difference between the Cost (as % of GNI) in Coal and Cost (as % of GNI) in Energy?
Offer a very short reply. -25.7. In the year 1984, what is the difference between the Cost (as % of GNI) of Coal and Cost (as % of GNI) of Water?
Your answer should be compact. -26.76. In the year 1984, what is the difference between the Cost (as % of GNI) in Minerals and Cost (as % of GNI) in Energy?
Provide a short and direct response. -26.65. In the year 1984, what is the difference between the Cost (as % of GNI) in Minerals and Cost (as % of GNI) in Water?
Your answer should be compact. -27.71. In the year 1984, what is the difference between the Cost (as % of GNI) in Energy and Cost (as % of GNI) in Water?
Offer a terse response. -1.06. In the year 1985, what is the difference between the Cost (as % of GNI) of Coal and Cost (as % of GNI) of Energy?
Your answer should be compact. -26.29. In the year 1985, what is the difference between the Cost (as % of GNI) in Coal and Cost (as % of GNI) in Water?
Provide a short and direct response. -27.15. In the year 1985, what is the difference between the Cost (as % of GNI) of Minerals and Cost (as % of GNI) of Energy?
Keep it short and to the point. -27.29. In the year 1985, what is the difference between the Cost (as % of GNI) in Minerals and Cost (as % of GNI) in Water?
Give a very brief answer. -28.14. In the year 1985, what is the difference between the Cost (as % of GNI) of Energy and Cost (as % of GNI) of Water?
Ensure brevity in your answer.  -0.86. What is the ratio of the Cost (as % of GNI) in Coal in 1978 to that in 1979?
Your response must be concise. 0.81. What is the ratio of the Cost (as % of GNI) of Minerals in 1978 to that in 1979?
Ensure brevity in your answer.  0.91. What is the ratio of the Cost (as % of GNI) in Energy in 1978 to that in 1979?
Ensure brevity in your answer.  0.41. What is the ratio of the Cost (as % of GNI) of Water in 1978 to that in 1979?
Your answer should be very brief. 0.42. What is the ratio of the Cost (as % of GNI) in Coal in 1978 to that in 1980?
Make the answer very short. 0.98. What is the ratio of the Cost (as % of GNI) of Minerals in 1978 to that in 1980?
Provide a succinct answer. 3.57. What is the ratio of the Cost (as % of GNI) in Energy in 1978 to that in 1980?
Provide a short and direct response. 0.54. What is the ratio of the Cost (as % of GNI) in Water in 1978 to that in 1980?
Keep it short and to the point. 0.55. What is the ratio of the Cost (as % of GNI) in Coal in 1978 to that in 1981?
Make the answer very short. 0.9. What is the ratio of the Cost (as % of GNI) of Minerals in 1978 to that in 1981?
Your response must be concise. 6.99. What is the ratio of the Cost (as % of GNI) in Energy in 1978 to that in 1981?
Offer a terse response. 0.93. What is the ratio of the Cost (as % of GNI) of Water in 1978 to that in 1981?
Make the answer very short. 0.92. What is the ratio of the Cost (as % of GNI) in Coal in 1978 to that in 1982?
Keep it short and to the point. 0.71. What is the ratio of the Cost (as % of GNI) of Minerals in 1978 to that in 1982?
Keep it short and to the point. 8.29. What is the ratio of the Cost (as % of GNI) in Energy in 1978 to that in 1982?
Give a very brief answer. 1.04. What is the ratio of the Cost (as % of GNI) in Water in 1978 to that in 1982?
Provide a short and direct response. 1.01. What is the ratio of the Cost (as % of GNI) of Coal in 1978 to that in 1983?
Your answer should be very brief. 0.51. What is the ratio of the Cost (as % of GNI) of Minerals in 1978 to that in 1983?
Offer a terse response. 6.27. What is the ratio of the Cost (as % of GNI) of Energy in 1978 to that in 1983?
Provide a short and direct response. 0.85. What is the ratio of the Cost (as % of GNI) of Water in 1978 to that in 1983?
Your answer should be very brief. 0.83. What is the ratio of the Cost (as % of GNI) in Coal in 1978 to that in 1984?
Make the answer very short. 0.33. What is the ratio of the Cost (as % of GNI) of Minerals in 1978 to that in 1984?
Your response must be concise. 9.26. What is the ratio of the Cost (as % of GNI) of Energy in 1978 to that in 1984?
Your answer should be compact. 0.59. What is the ratio of the Cost (as % of GNI) of Water in 1978 to that in 1984?
Offer a very short reply. 0.59. What is the ratio of the Cost (as % of GNI) in Coal in 1978 to that in 1985?
Provide a succinct answer. 0.32. What is the ratio of the Cost (as % of GNI) in Minerals in 1978 to that in 1985?
Provide a succinct answer. 11.04. What is the ratio of the Cost (as % of GNI) in Energy in 1978 to that in 1985?
Make the answer very short. 0.58. What is the ratio of the Cost (as % of GNI) of Water in 1978 to that in 1985?
Provide a succinct answer. 0.58. What is the ratio of the Cost (as % of GNI) in Coal in 1979 to that in 1980?
Give a very brief answer. 1.22. What is the ratio of the Cost (as % of GNI) of Minerals in 1979 to that in 1980?
Offer a terse response. 3.91. What is the ratio of the Cost (as % of GNI) of Energy in 1979 to that in 1980?
Provide a succinct answer. 1.32. What is the ratio of the Cost (as % of GNI) in Water in 1979 to that in 1980?
Give a very brief answer. 1.31. What is the ratio of the Cost (as % of GNI) of Coal in 1979 to that in 1981?
Offer a terse response. 1.11. What is the ratio of the Cost (as % of GNI) in Minerals in 1979 to that in 1981?
Give a very brief answer. 7.66. What is the ratio of the Cost (as % of GNI) of Energy in 1979 to that in 1981?
Your answer should be very brief. 2.25. What is the ratio of the Cost (as % of GNI) in Water in 1979 to that in 1981?
Provide a short and direct response. 2.21. What is the ratio of the Cost (as % of GNI) of Coal in 1979 to that in 1982?
Offer a terse response. 0.88. What is the ratio of the Cost (as % of GNI) in Minerals in 1979 to that in 1982?
Offer a very short reply. 9.09. What is the ratio of the Cost (as % of GNI) in Energy in 1979 to that in 1982?
Provide a succinct answer. 2.52. What is the ratio of the Cost (as % of GNI) of Water in 1979 to that in 1982?
Ensure brevity in your answer.  2.42. What is the ratio of the Cost (as % of GNI) of Coal in 1979 to that in 1983?
Your answer should be compact. 0.63. What is the ratio of the Cost (as % of GNI) in Minerals in 1979 to that in 1983?
Your answer should be very brief. 6.87. What is the ratio of the Cost (as % of GNI) in Energy in 1979 to that in 1983?
Provide a succinct answer. 2.06. What is the ratio of the Cost (as % of GNI) of Water in 1979 to that in 1983?
Ensure brevity in your answer.  2. What is the ratio of the Cost (as % of GNI) in Coal in 1979 to that in 1984?
Provide a short and direct response. 0.41. What is the ratio of the Cost (as % of GNI) in Minerals in 1979 to that in 1984?
Your answer should be compact. 10.15. What is the ratio of the Cost (as % of GNI) in Energy in 1979 to that in 1984?
Ensure brevity in your answer.  1.44. What is the ratio of the Cost (as % of GNI) of Water in 1979 to that in 1984?
Provide a short and direct response. 1.4. What is the ratio of the Cost (as % of GNI) of Coal in 1979 to that in 1985?
Provide a succinct answer. 0.4. What is the ratio of the Cost (as % of GNI) of Minerals in 1979 to that in 1985?
Your answer should be very brief. 12.1. What is the ratio of the Cost (as % of GNI) of Energy in 1979 to that in 1985?
Provide a short and direct response. 1.41. What is the ratio of the Cost (as % of GNI) of Water in 1979 to that in 1985?
Make the answer very short. 1.38. What is the ratio of the Cost (as % of GNI) of Coal in 1980 to that in 1981?
Ensure brevity in your answer.  0.91. What is the ratio of the Cost (as % of GNI) of Minerals in 1980 to that in 1981?
Provide a short and direct response. 1.96. What is the ratio of the Cost (as % of GNI) in Energy in 1980 to that in 1981?
Provide a succinct answer. 1.71. What is the ratio of the Cost (as % of GNI) in Water in 1980 to that in 1981?
Give a very brief answer. 1.68. What is the ratio of the Cost (as % of GNI) of Coal in 1980 to that in 1982?
Your response must be concise. 0.72. What is the ratio of the Cost (as % of GNI) in Minerals in 1980 to that in 1982?
Give a very brief answer. 2.33. What is the ratio of the Cost (as % of GNI) in Energy in 1980 to that in 1982?
Keep it short and to the point. 1.91. What is the ratio of the Cost (as % of GNI) of Water in 1980 to that in 1982?
Make the answer very short. 1.85. What is the ratio of the Cost (as % of GNI) in Coal in 1980 to that in 1983?
Offer a very short reply. 0.52. What is the ratio of the Cost (as % of GNI) in Minerals in 1980 to that in 1983?
Provide a short and direct response. 1.76. What is the ratio of the Cost (as % of GNI) of Energy in 1980 to that in 1983?
Your answer should be very brief. 1.57. What is the ratio of the Cost (as % of GNI) in Water in 1980 to that in 1983?
Provide a succinct answer. 1.52. What is the ratio of the Cost (as % of GNI) in Coal in 1980 to that in 1984?
Your answer should be compact. 0.34. What is the ratio of the Cost (as % of GNI) in Minerals in 1980 to that in 1984?
Provide a succinct answer. 2.6. What is the ratio of the Cost (as % of GNI) of Energy in 1980 to that in 1984?
Offer a terse response. 1.09. What is the ratio of the Cost (as % of GNI) in Water in 1980 to that in 1984?
Provide a short and direct response. 1.07. What is the ratio of the Cost (as % of GNI) of Coal in 1980 to that in 1985?
Make the answer very short. 0.33. What is the ratio of the Cost (as % of GNI) in Minerals in 1980 to that in 1985?
Ensure brevity in your answer.  3.1. What is the ratio of the Cost (as % of GNI) in Energy in 1980 to that in 1985?
Your answer should be compact. 1.07. What is the ratio of the Cost (as % of GNI) of Water in 1980 to that in 1985?
Your answer should be very brief. 1.05. What is the ratio of the Cost (as % of GNI) of Coal in 1981 to that in 1982?
Provide a succinct answer. 0.79. What is the ratio of the Cost (as % of GNI) of Minerals in 1981 to that in 1982?
Your answer should be very brief. 1.19. What is the ratio of the Cost (as % of GNI) in Energy in 1981 to that in 1982?
Offer a very short reply. 1.12. What is the ratio of the Cost (as % of GNI) in Water in 1981 to that in 1982?
Offer a terse response. 1.1. What is the ratio of the Cost (as % of GNI) of Coal in 1981 to that in 1983?
Make the answer very short. 0.57. What is the ratio of the Cost (as % of GNI) in Minerals in 1981 to that in 1983?
Offer a terse response. 0.9. What is the ratio of the Cost (as % of GNI) in Energy in 1981 to that in 1983?
Give a very brief answer. 0.92. What is the ratio of the Cost (as % of GNI) in Water in 1981 to that in 1983?
Your answer should be very brief. 0.9. What is the ratio of the Cost (as % of GNI) of Coal in 1981 to that in 1984?
Ensure brevity in your answer.  0.37. What is the ratio of the Cost (as % of GNI) in Minerals in 1981 to that in 1984?
Ensure brevity in your answer.  1.32. What is the ratio of the Cost (as % of GNI) in Energy in 1981 to that in 1984?
Your response must be concise. 0.64. What is the ratio of the Cost (as % of GNI) in Water in 1981 to that in 1984?
Provide a succinct answer. 0.64. What is the ratio of the Cost (as % of GNI) in Coal in 1981 to that in 1985?
Offer a very short reply. 0.36. What is the ratio of the Cost (as % of GNI) in Minerals in 1981 to that in 1985?
Your answer should be very brief. 1.58. What is the ratio of the Cost (as % of GNI) in Energy in 1981 to that in 1985?
Ensure brevity in your answer.  0.63. What is the ratio of the Cost (as % of GNI) of Water in 1981 to that in 1985?
Provide a short and direct response. 0.63. What is the ratio of the Cost (as % of GNI) in Coal in 1982 to that in 1983?
Your answer should be very brief. 0.72. What is the ratio of the Cost (as % of GNI) in Minerals in 1982 to that in 1983?
Give a very brief answer. 0.76. What is the ratio of the Cost (as % of GNI) in Energy in 1982 to that in 1983?
Keep it short and to the point. 0.82. What is the ratio of the Cost (as % of GNI) in Water in 1982 to that in 1983?
Ensure brevity in your answer.  0.82. What is the ratio of the Cost (as % of GNI) in Coal in 1982 to that in 1984?
Offer a very short reply. 0.47. What is the ratio of the Cost (as % of GNI) in Minerals in 1982 to that in 1984?
Offer a very short reply. 1.12. What is the ratio of the Cost (as % of GNI) of Energy in 1982 to that in 1984?
Make the answer very short. 0.57. What is the ratio of the Cost (as % of GNI) in Water in 1982 to that in 1984?
Your response must be concise. 0.58. What is the ratio of the Cost (as % of GNI) in Coal in 1982 to that in 1985?
Your answer should be compact. 0.45. What is the ratio of the Cost (as % of GNI) of Minerals in 1982 to that in 1985?
Your response must be concise. 1.33. What is the ratio of the Cost (as % of GNI) in Energy in 1982 to that in 1985?
Ensure brevity in your answer.  0.56. What is the ratio of the Cost (as % of GNI) in Water in 1982 to that in 1985?
Make the answer very short. 0.57. What is the ratio of the Cost (as % of GNI) in Coal in 1983 to that in 1984?
Provide a short and direct response. 0.65. What is the ratio of the Cost (as % of GNI) of Minerals in 1983 to that in 1984?
Make the answer very short. 1.48. What is the ratio of the Cost (as % of GNI) in Energy in 1983 to that in 1984?
Your answer should be very brief. 0.7. What is the ratio of the Cost (as % of GNI) in Water in 1983 to that in 1984?
Offer a terse response. 0.7. What is the ratio of the Cost (as % of GNI) in Coal in 1983 to that in 1985?
Make the answer very short. 0.63. What is the ratio of the Cost (as % of GNI) in Minerals in 1983 to that in 1985?
Make the answer very short. 1.76. What is the ratio of the Cost (as % of GNI) in Energy in 1983 to that in 1985?
Offer a terse response. 0.68. What is the ratio of the Cost (as % of GNI) in Water in 1983 to that in 1985?
Your response must be concise. 0.69. What is the ratio of the Cost (as % of GNI) in Coal in 1984 to that in 1985?
Ensure brevity in your answer.  0.96. What is the ratio of the Cost (as % of GNI) in Minerals in 1984 to that in 1985?
Your answer should be very brief. 1.19. What is the ratio of the Cost (as % of GNI) in Energy in 1984 to that in 1985?
Your answer should be very brief. 0.98. What is the ratio of the Cost (as % of GNI) of Water in 1984 to that in 1985?
Your response must be concise. 0.98. What is the difference between the highest and the second highest Cost (as % of GNI) in Coal?
Ensure brevity in your answer.  0.04. What is the difference between the highest and the second highest Cost (as % of GNI) of Minerals?
Make the answer very short. 0. What is the difference between the highest and the second highest Cost (as % of GNI) of Energy?
Offer a terse response. 9.25. What is the difference between the highest and the second highest Cost (as % of GNI) in Water?
Keep it short and to the point. 9.21. What is the difference between the highest and the lowest Cost (as % of GNI) in Coal?
Keep it short and to the point. 0.68. What is the difference between the highest and the lowest Cost (as % of GNI) of Minerals?
Make the answer very short. 0.05. What is the difference between the highest and the lowest Cost (as % of GNI) of Energy?
Your response must be concise. 23.13. What is the difference between the highest and the lowest Cost (as % of GNI) in Water?
Give a very brief answer. 22.81. 